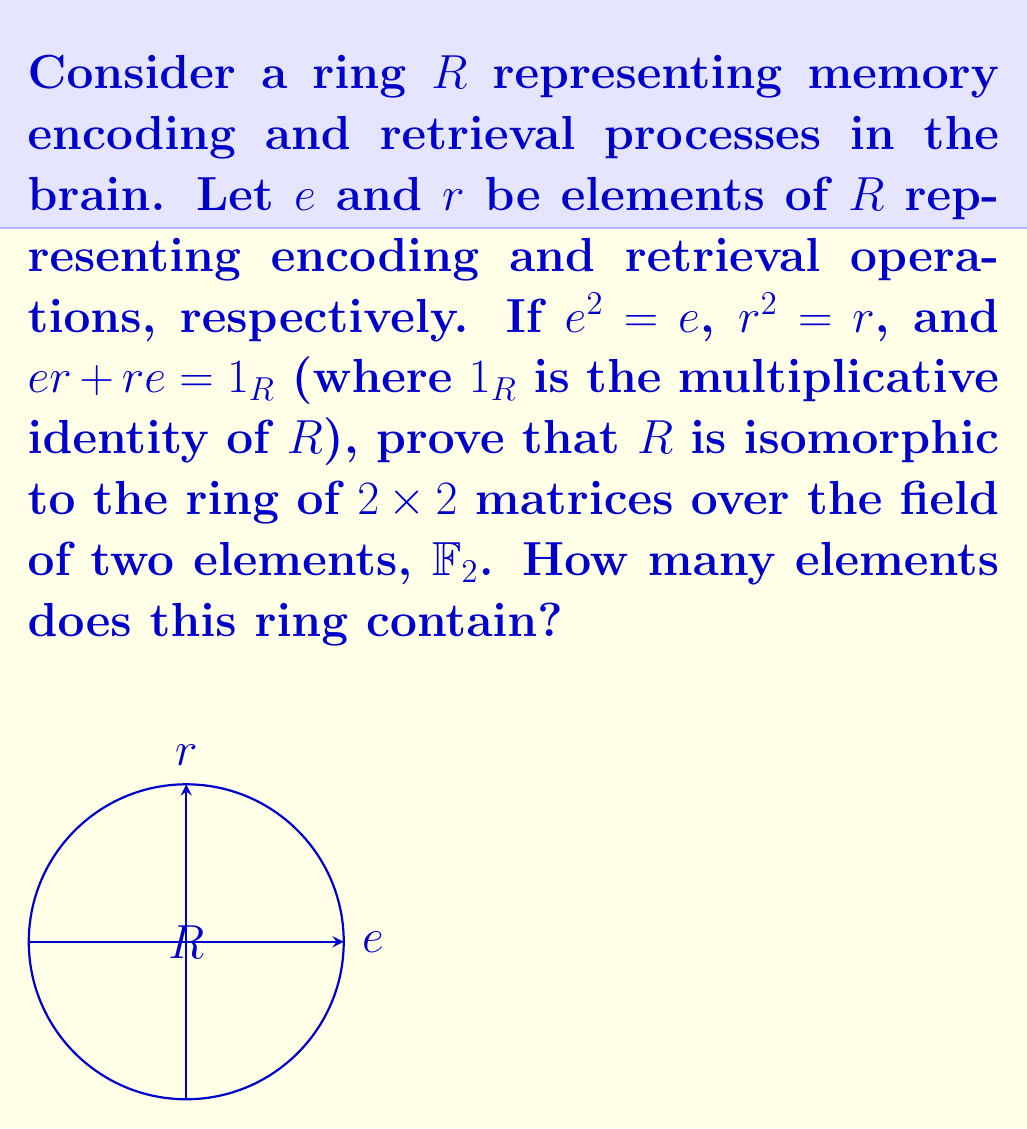Teach me how to tackle this problem. 1) First, we need to show that $R$ is isomorphic to the ring of $2 \times 2$ matrices over $\mathbb{F}_2$. Let's call this matrix ring $M_2(\mathbb{F}_2)$.

2) Define a map $\phi: R \rightarrow M_2(\mathbb{F}_2)$ as follows:

   $\phi(e) = \begin{pmatrix} 1 & 0 \\ 0 & 0 \end{pmatrix}$
   $\phi(r) = \begin{pmatrix} 0 & 1 \\ 1 & 1 \end{pmatrix}$

3) We need to verify that this map preserves the given relations:

   $\phi(e)^2 = \begin{pmatrix} 1 & 0 \\ 0 & 0 \end{pmatrix} = \phi(e)$
   $\phi(r)^2 = \begin{pmatrix} 1 & 1 \\ 1 & 1 \end{pmatrix} = \phi(r)$
   $\phi(e)\phi(r) + \phi(r)\phi(e) = \begin{pmatrix} 0 & 1 \\ 0 & 0 \end{pmatrix} + \begin{pmatrix} 1 & 0 \\ 1 & 0 \end{pmatrix} = \begin{pmatrix} 1 & 1 \\ 1 & 0 \end{pmatrix} = \phi(1_R)$

4) This map is surjective because every matrix in $M_2(\mathbb{F}_2)$ can be written as a linear combination of $\phi(e)$, $\phi(r)$, $\phi(e)\phi(r)$, and $\phi(r)\phi(e)$.

5) It's also injective because if $\phi(x) = 0$, then $x$ must be 0 in $R$.

6) Therefore, $\phi$ is an isomorphism, and $R \cong M_2(\mathbb{F}_2)$.

7) To count the elements in $M_2(\mathbb{F}_2)$, note that each entry can be either 0 or 1, and there are 4 entries.

8) Thus, the total number of elements is $2^4 = 16$.
Answer: 16 elements 